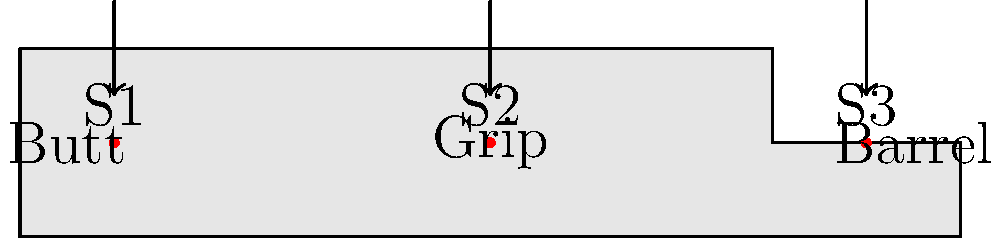As a news editor covering prolonged combat situations, you need to understand the ergonomics of rifle designs. The diagram shows three primary stress points (S1, S2, S3) on a typical rifle during extended use. If the force exerted at each point is represented by $F_1$, $F_2$, and $F_3$ respectively, and the total force experienced by the user is $F_T = F_1 + F_2 + F_3$, which stress point should rifle designers focus on most to reduce user fatigue, assuming $F_1 = 0.3F_T$, $F_2 = 0.5F_T$, and $F_3 = 0.2F_T$? To determine which stress point rifle designers should focus on most to reduce user fatigue, we need to analyze the force distribution across the three stress points:

1. Calculate the relative force at each stress point:
   S1 (Butt): $F_1 = 0.3F_T$
   S2 (Grip): $F_2 = 0.5F_T$
   S3 (Barrel): $F_3 = 0.2F_T$

2. Compare the forces:
   $F_2 > F_1 > F_3$

3. Identify the stress point with the highest force:
   S2 (Grip) experiences the highest force at $0.5F_T$, which is 50% of the total force.

4. Consider the impact on user fatigue:
   The grip area (S2) bears the most stress during prolonged use, making it the most critical point for fatigue reduction.

5. Ergonomic implications:
   Focusing on improving the grip design would have the most significant impact on reducing overall user fatigue during extended combat situations.

Therefore, rifle designers should prioritize the grip area (S2) to most effectively reduce user fatigue during prolonged use.
Answer: Grip (S2) 